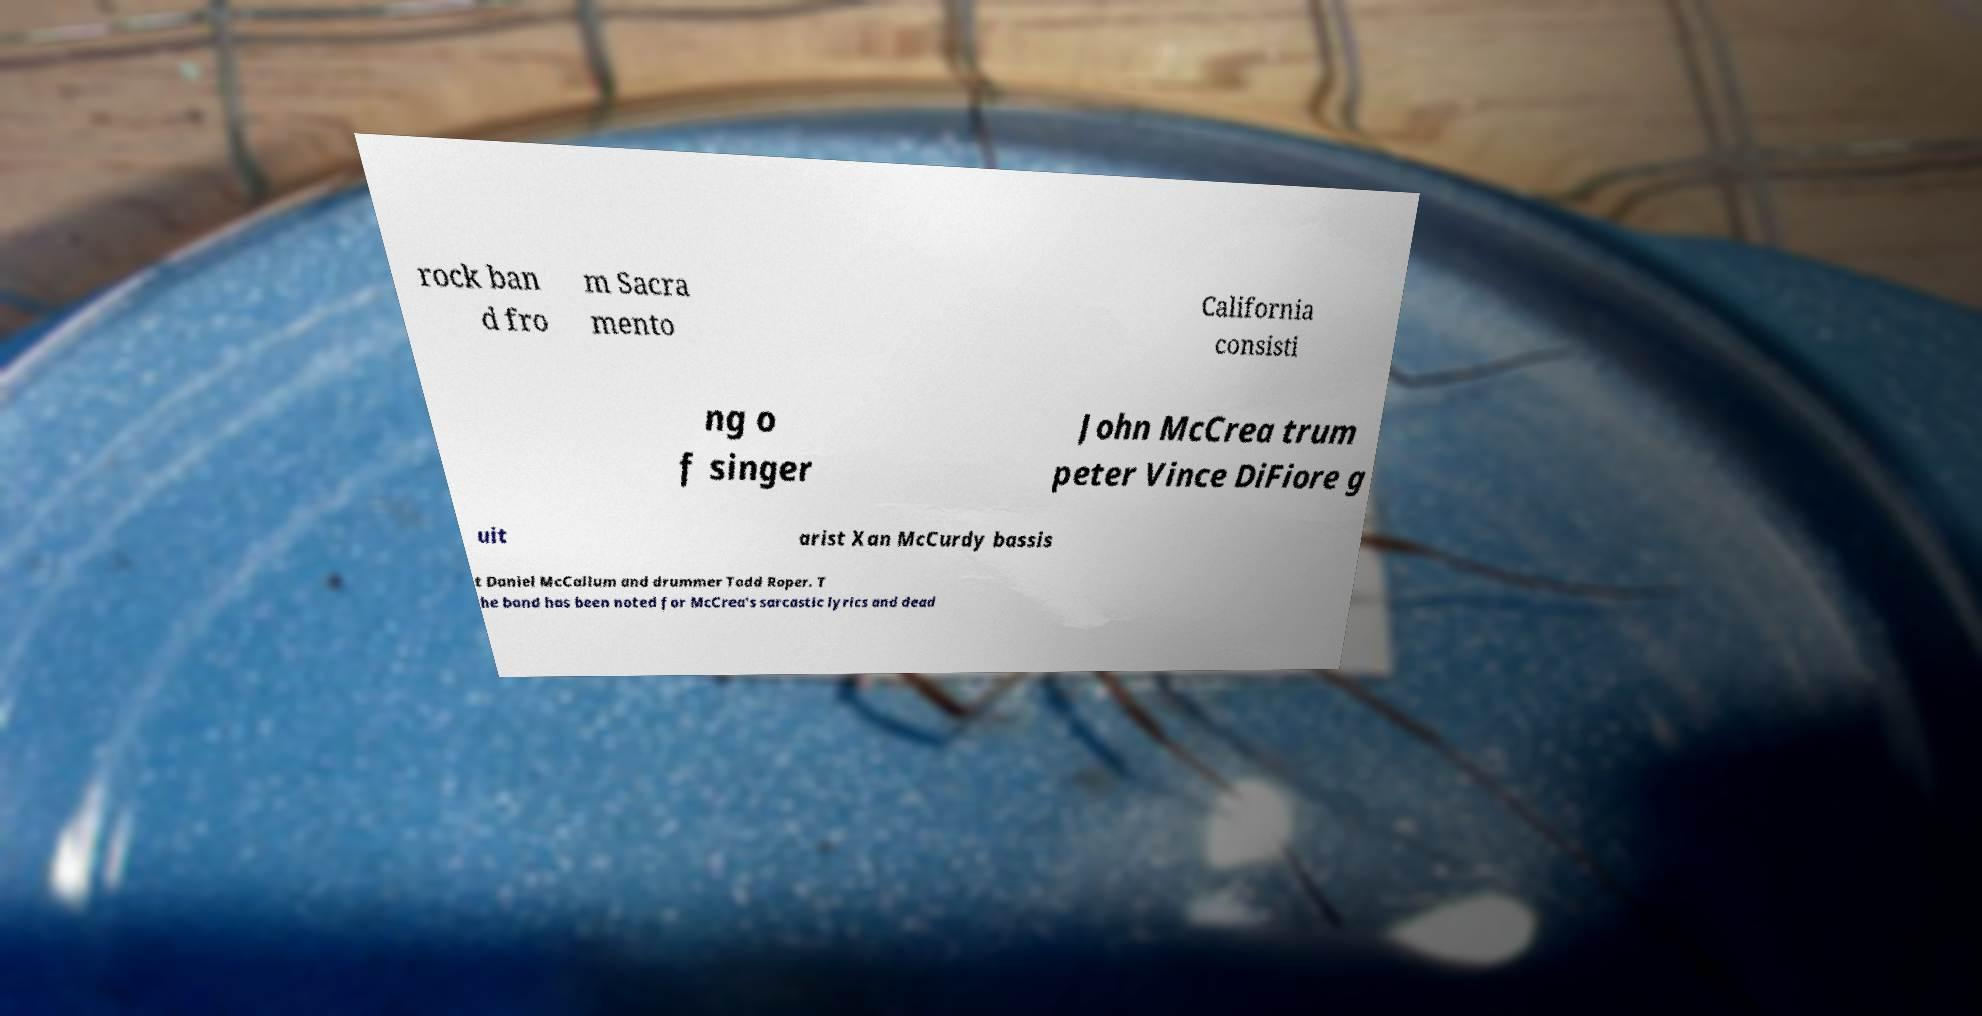Can you accurately transcribe the text from the provided image for me? rock ban d fro m Sacra mento California consisti ng o f singer John McCrea trum peter Vince DiFiore g uit arist Xan McCurdy bassis t Daniel McCallum and drummer Todd Roper. T he band has been noted for McCrea's sarcastic lyrics and dead 